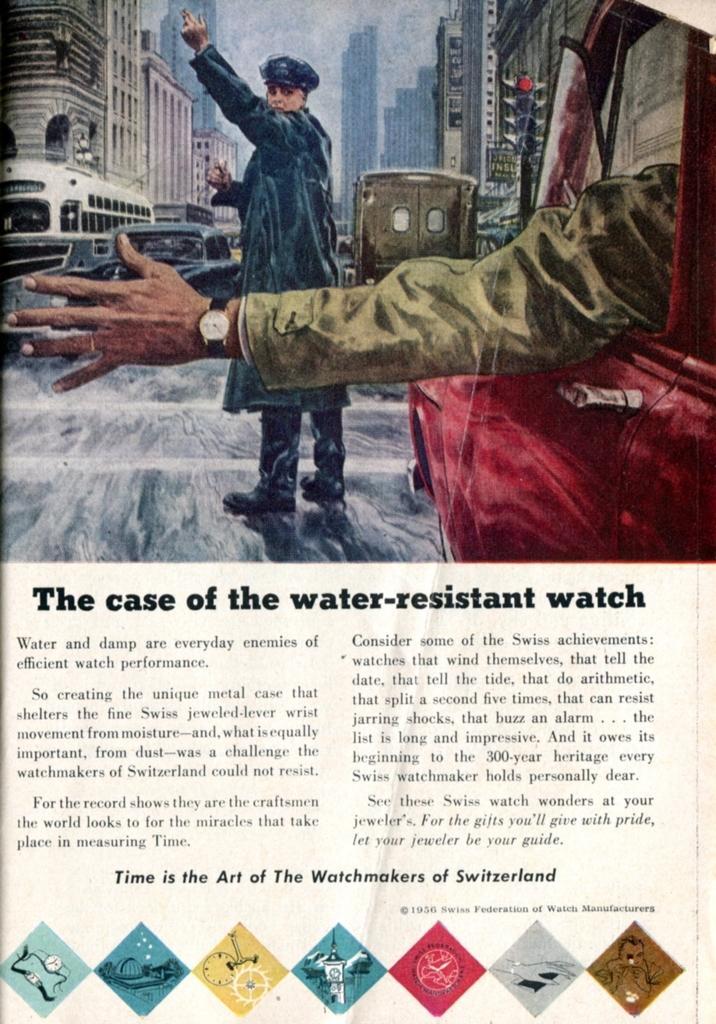Please provide a concise description of this image. This image is about a painting, in this image there is a traffic cop controlling the traffic, around him there are cars, in the background of the picture there are buildings and there is written text on the image. 